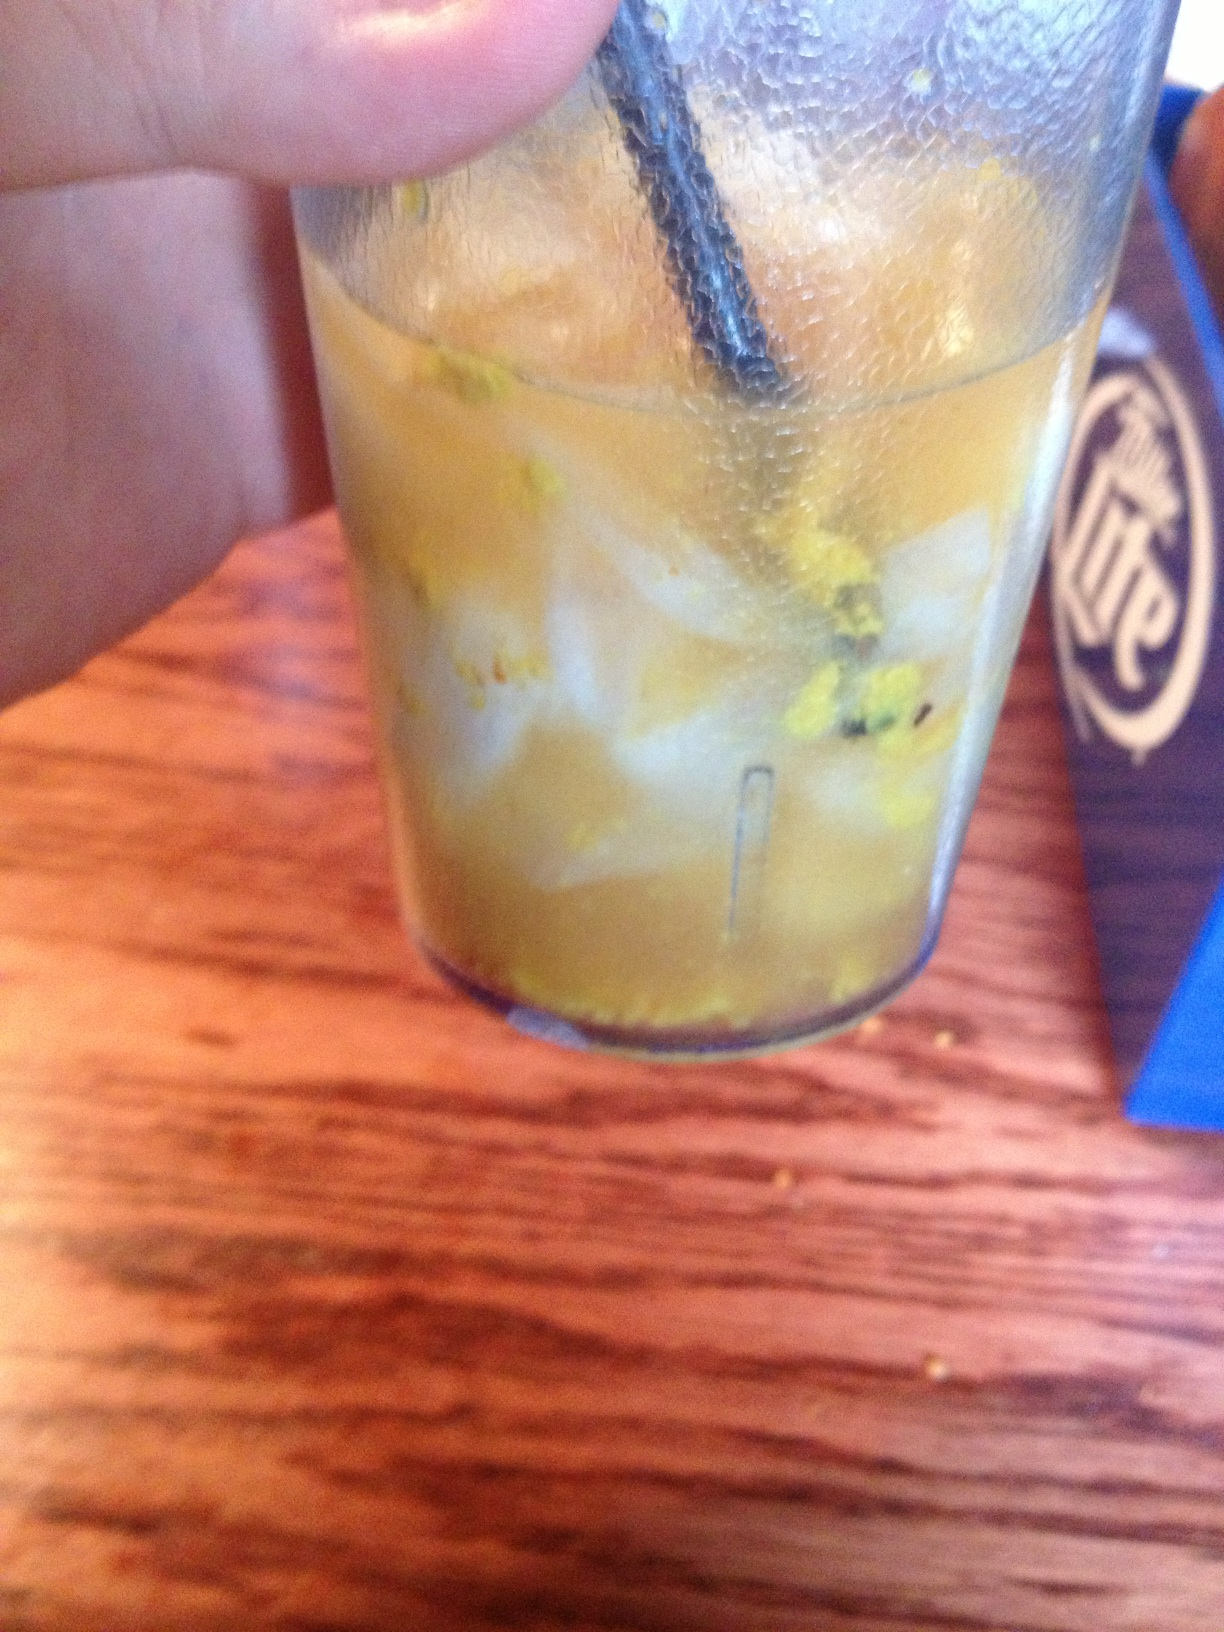This drink has a peculiar look. Can you tell me what it might be? The drink in the image seems to have some unique ingredients, possibly including shredded citrus peel or another type of garnish. It could be a custom cocktail or a special house drink. I'd recommend asking the server for details on what exactly it contains. What are some common ingredients that might give a drink this appearance? A drink with this appearance might commonly include ingredients like citrus zest, ground spices, or even infusions of herbs or fruits. Sometimes drinks are garnished with edible flowers or other decorative elements which can alter their look. Asking the restaurant for an ingredient list can provide clarity. 